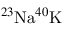<formula> <loc_0><loc_0><loc_500><loc_500>^ { 2 3 } N a ^ { 4 0 } K</formula> 